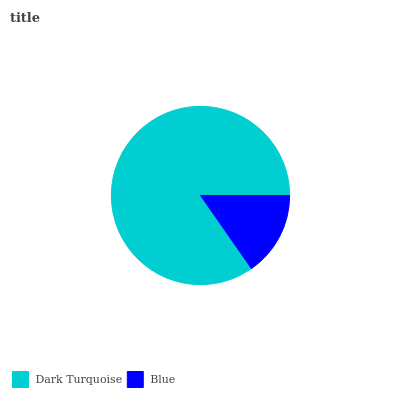Is Blue the minimum?
Answer yes or no. Yes. Is Dark Turquoise the maximum?
Answer yes or no. Yes. Is Blue the maximum?
Answer yes or no. No. Is Dark Turquoise greater than Blue?
Answer yes or no. Yes. Is Blue less than Dark Turquoise?
Answer yes or no. Yes. Is Blue greater than Dark Turquoise?
Answer yes or no. No. Is Dark Turquoise less than Blue?
Answer yes or no. No. Is Dark Turquoise the high median?
Answer yes or no. Yes. Is Blue the low median?
Answer yes or no. Yes. Is Blue the high median?
Answer yes or no. No. Is Dark Turquoise the low median?
Answer yes or no. No. 